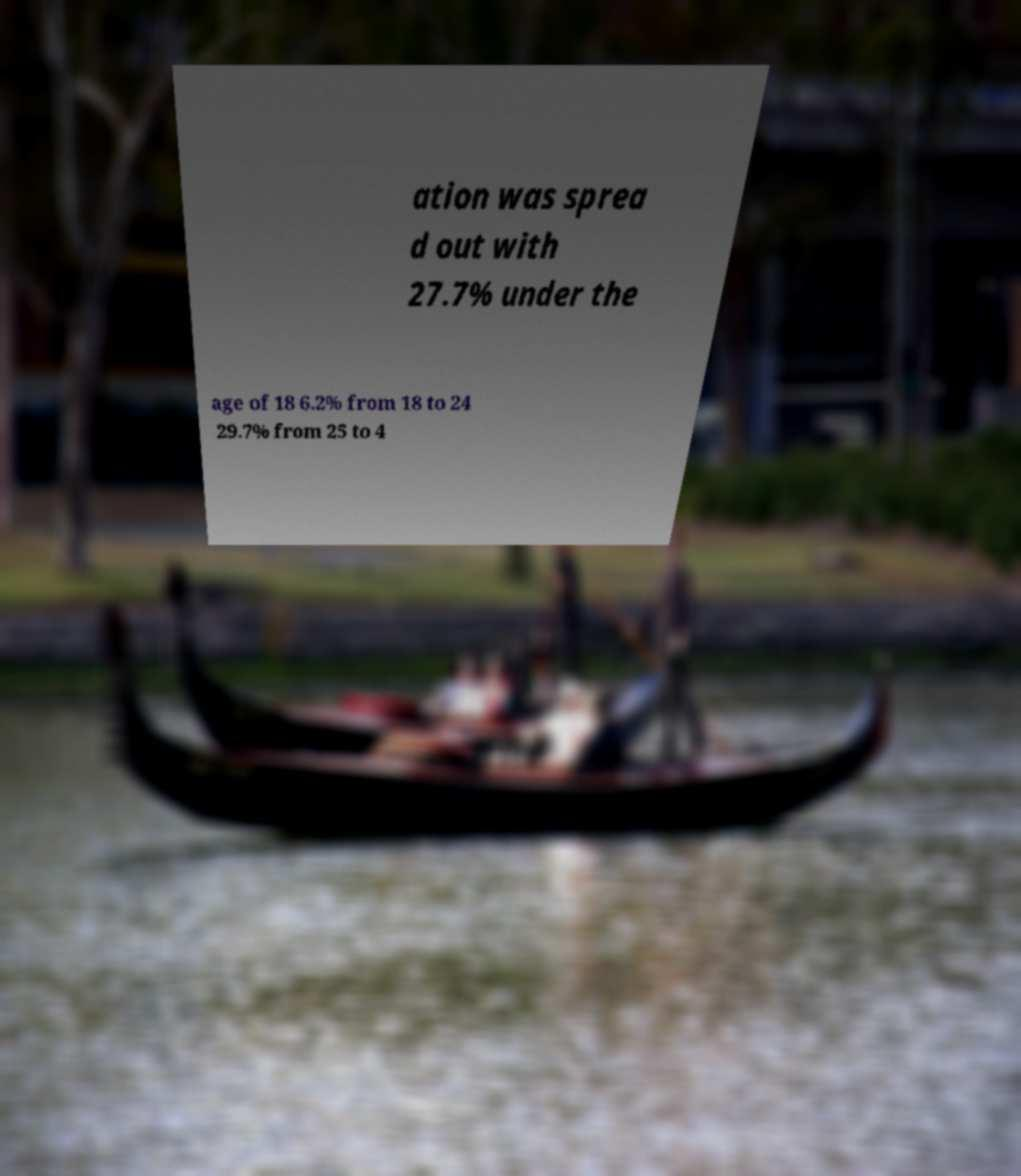Please read and relay the text visible in this image. What does it say? ation was sprea d out with 27.7% under the age of 18 6.2% from 18 to 24 29.7% from 25 to 4 